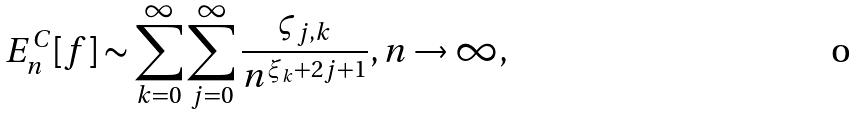Convert formula to latex. <formula><loc_0><loc_0><loc_500><loc_500>E _ { n } ^ { C } [ f ] \sim \sum _ { k = 0 } ^ { \infty } \sum _ { j = 0 } ^ { \infty } \frac { \varsigma _ { j , k } } { n ^ { \xi _ { k } + 2 j + 1 } } , n \rightarrow \infty ,</formula> 